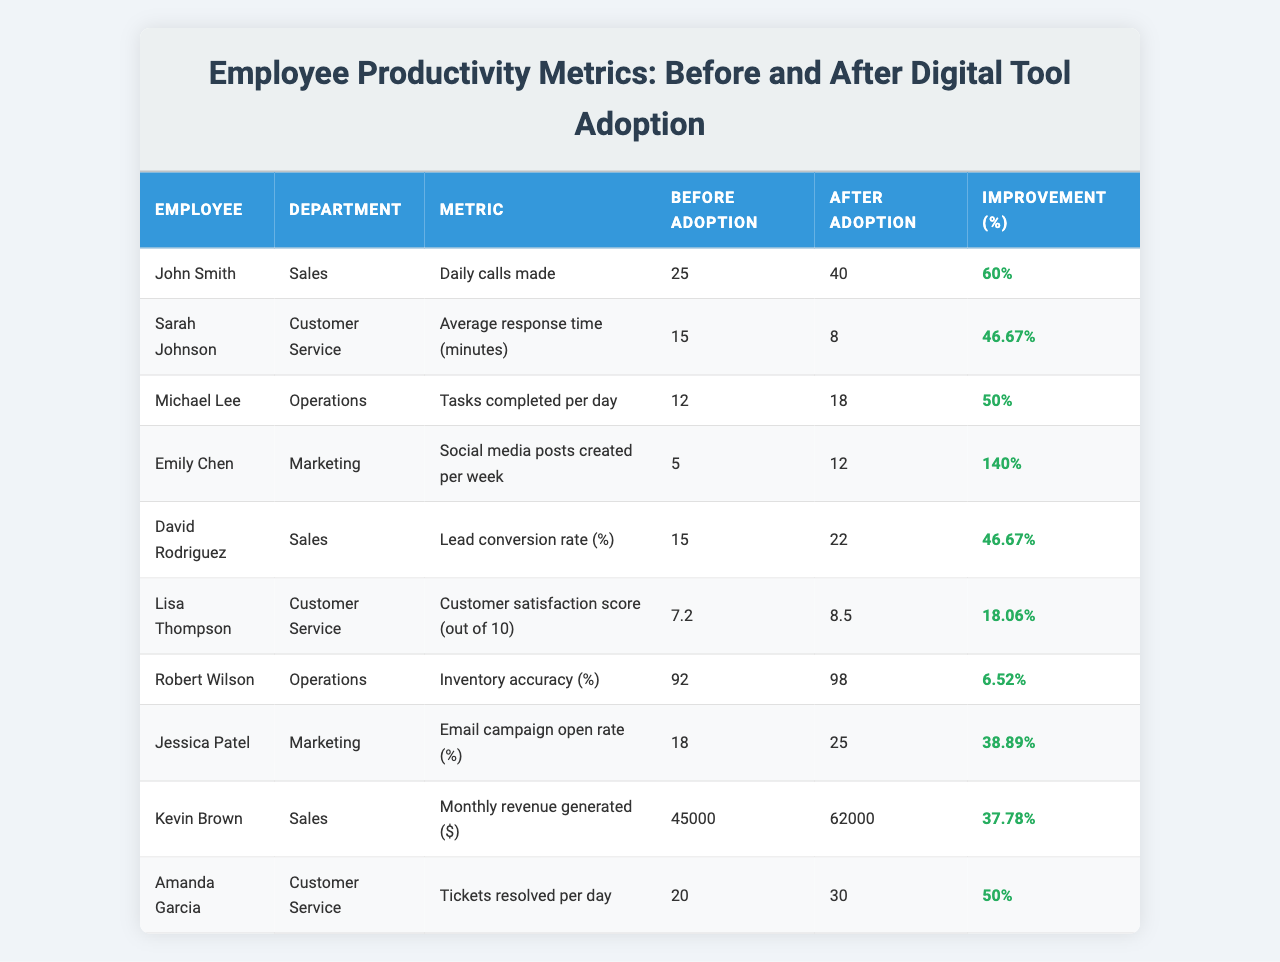What was the percentage improvement in daily calls made by John Smith after digital tool adoption? The table shows that John Smith made 25 calls before adoption and 40 calls after adoption. The improvement percentage is provided as 60%.
Answer: 60% What was the average response time for Sarah Johnson before and after digital tool adoption? The table indicates that Sarah Johnson's average response time was 15 minutes before adoption and 8 minutes after adoption. To find the average, add the two values and divide by 2: (15 + 8) / 2 = 11.5 minutes.
Answer: 11.5 minutes Which employee had the highest percentage improvement in their metric after adopting the digital tool? Looking at the improvement percentages, Emily Chen had the highest percentage improvement at 140%, as indicated in the table.
Answer: Emily Chen What was the difference in tasks Michael Lee completed per day before and after adopting the digital tool? The table shows Michael Lee completed 12 tasks before and 18 tasks after adopting the tool. The difference is calculated as 18 - 12 = 6 tasks.
Answer: 6 tasks Did the average customer satisfaction score for Lisa Thompson improve after digital tool adoption? The table shows Lisa Thompson's customer satisfaction score before adoption was 7.2 and after adoption was 8.5. Since 8.5 is greater than 7.2, the score improved.
Answer: Yes What was the combined revenue generated by Kevin Brown and the improvement percentage in their metrics after digital tool adoption? Kevin Brown generated $45,000 before and $62,000 after adoption. The combined revenue is calculated by adding both values: 45000 + 62000 = 107000. The improvement percentage is 37.78%, which is also indicated in the table.
Answer: $107,000 and 37.78% How many more tickets could Amanda Garcia resolve per day after adopting the digital tool? Amanda Garcia resolved 20 tickets per day before and 30 tickets per day after the adoption. The additional tickets resolved are calculated as 30 - 20 = 10 tickets.
Answer: 10 tickets What was the average improvement percentage across all employees in the table? First, sum the improvement percentages: 60 + 46.67 + 50 + 140 + 46.67 + 18.06 + 6.52 + 38.89 + 37.78 + 50 = 445.29. Then divide by the number of employees (10): 445.29 / 10 = 44.529%.
Answer: 44.53% Is it true that Robert Wilson's inventory accuracy improved by more than 10% after the tool adoption? Robert Wilson's inventory accuracy improved from 92% to 98%, which is an improvement of 6%. Since 6% is less than 10%, the statement is false.
Answer: No Which metric had the greatest improvement in percentage and what was that improvement? The metric with the greatest improvement was "Social media posts created per week" by Emily Chen, which improved by 140%. This is shown in the table.
Answer: 140% 